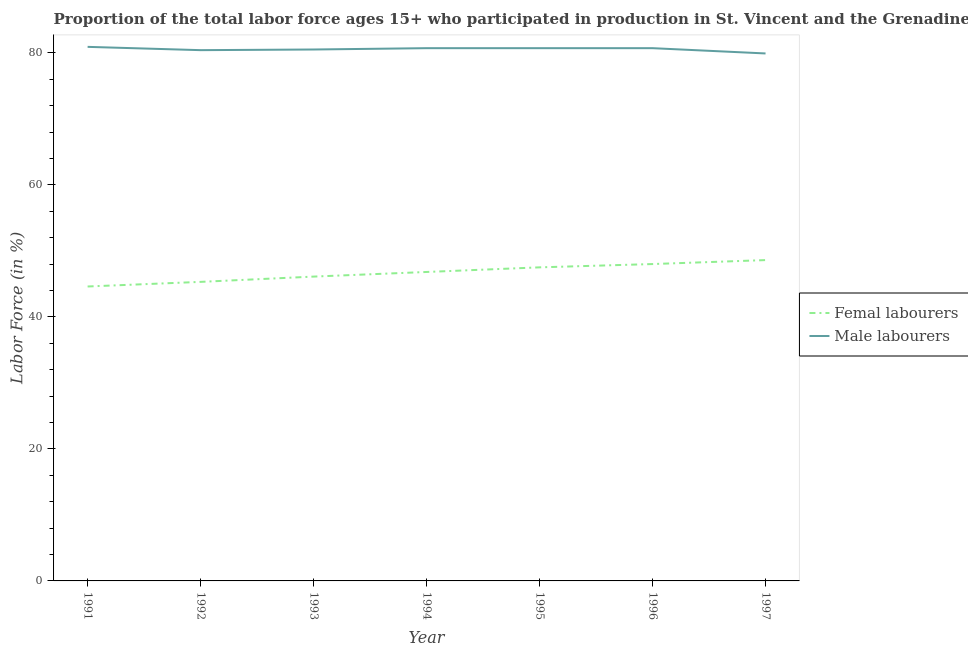What is the percentage of male labour force in 1997?
Your response must be concise. 79.9. Across all years, what is the maximum percentage of male labour force?
Offer a terse response. 80.9. Across all years, what is the minimum percentage of male labour force?
Provide a succinct answer. 79.9. In which year was the percentage of male labour force maximum?
Provide a short and direct response. 1991. In which year was the percentage of male labour force minimum?
Ensure brevity in your answer.  1997. What is the total percentage of male labour force in the graph?
Offer a terse response. 563.8. What is the difference between the percentage of female labor force in 1991 and that in 1996?
Make the answer very short. -3.4. What is the difference between the percentage of male labour force in 1996 and the percentage of female labor force in 1993?
Provide a succinct answer. 34.6. What is the average percentage of male labour force per year?
Your answer should be compact. 80.54. In the year 1997, what is the difference between the percentage of female labor force and percentage of male labour force?
Your response must be concise. -31.3. In how many years, is the percentage of male labour force greater than 28 %?
Your response must be concise. 7. What is the ratio of the percentage of female labor force in 1991 to that in 1994?
Ensure brevity in your answer.  0.95. Is the percentage of male labour force in 1996 less than that in 1997?
Your answer should be very brief. No. Is the difference between the percentage of female labor force in 1996 and 1997 greater than the difference between the percentage of male labour force in 1996 and 1997?
Your response must be concise. No. What is the difference between the highest and the second highest percentage of female labor force?
Offer a terse response. 0.6. What is the difference between the highest and the lowest percentage of male labour force?
Give a very brief answer. 1. In how many years, is the percentage of male labour force greater than the average percentage of male labour force taken over all years?
Ensure brevity in your answer.  4. Does the percentage of male labour force monotonically increase over the years?
Provide a short and direct response. No. Is the percentage of female labor force strictly less than the percentage of male labour force over the years?
Provide a short and direct response. Yes. How many lines are there?
Give a very brief answer. 2. Does the graph contain any zero values?
Your answer should be compact. No. Does the graph contain grids?
Give a very brief answer. No. How many legend labels are there?
Provide a short and direct response. 2. What is the title of the graph?
Give a very brief answer. Proportion of the total labor force ages 15+ who participated in production in St. Vincent and the Grenadines. What is the label or title of the X-axis?
Your answer should be very brief. Year. What is the label or title of the Y-axis?
Give a very brief answer. Labor Force (in %). What is the Labor Force (in %) of Femal labourers in 1991?
Provide a short and direct response. 44.6. What is the Labor Force (in %) in Male labourers in 1991?
Keep it short and to the point. 80.9. What is the Labor Force (in %) in Femal labourers in 1992?
Provide a succinct answer. 45.3. What is the Labor Force (in %) in Male labourers in 1992?
Provide a succinct answer. 80.4. What is the Labor Force (in %) in Femal labourers in 1993?
Provide a succinct answer. 46.1. What is the Labor Force (in %) in Male labourers in 1993?
Offer a terse response. 80.5. What is the Labor Force (in %) in Femal labourers in 1994?
Your answer should be compact. 46.8. What is the Labor Force (in %) of Male labourers in 1994?
Provide a short and direct response. 80.7. What is the Labor Force (in %) of Femal labourers in 1995?
Your response must be concise. 47.5. What is the Labor Force (in %) of Male labourers in 1995?
Your answer should be compact. 80.7. What is the Labor Force (in %) in Femal labourers in 1996?
Provide a succinct answer. 48. What is the Labor Force (in %) in Male labourers in 1996?
Offer a very short reply. 80.7. What is the Labor Force (in %) of Femal labourers in 1997?
Your answer should be compact. 48.6. What is the Labor Force (in %) in Male labourers in 1997?
Your answer should be very brief. 79.9. Across all years, what is the maximum Labor Force (in %) of Femal labourers?
Make the answer very short. 48.6. Across all years, what is the maximum Labor Force (in %) of Male labourers?
Provide a succinct answer. 80.9. Across all years, what is the minimum Labor Force (in %) in Femal labourers?
Ensure brevity in your answer.  44.6. Across all years, what is the minimum Labor Force (in %) of Male labourers?
Your answer should be compact. 79.9. What is the total Labor Force (in %) in Femal labourers in the graph?
Make the answer very short. 326.9. What is the total Labor Force (in %) in Male labourers in the graph?
Provide a short and direct response. 563.8. What is the difference between the Labor Force (in %) in Femal labourers in 1991 and that in 1992?
Offer a very short reply. -0.7. What is the difference between the Labor Force (in %) of Femal labourers in 1991 and that in 1993?
Your response must be concise. -1.5. What is the difference between the Labor Force (in %) of Male labourers in 1991 and that in 1993?
Offer a terse response. 0.4. What is the difference between the Labor Force (in %) in Femal labourers in 1991 and that in 1995?
Ensure brevity in your answer.  -2.9. What is the difference between the Labor Force (in %) of Male labourers in 1991 and that in 1997?
Your answer should be very brief. 1. What is the difference between the Labor Force (in %) of Male labourers in 1992 and that in 1994?
Provide a succinct answer. -0.3. What is the difference between the Labor Force (in %) of Male labourers in 1992 and that in 1995?
Offer a very short reply. -0.3. What is the difference between the Labor Force (in %) of Femal labourers in 1992 and that in 1996?
Provide a short and direct response. -2.7. What is the difference between the Labor Force (in %) in Male labourers in 1992 and that in 1996?
Make the answer very short. -0.3. What is the difference between the Labor Force (in %) of Male labourers in 1992 and that in 1997?
Offer a very short reply. 0.5. What is the difference between the Labor Force (in %) of Male labourers in 1993 and that in 1994?
Your answer should be compact. -0.2. What is the difference between the Labor Force (in %) of Male labourers in 1993 and that in 1995?
Keep it short and to the point. -0.2. What is the difference between the Labor Force (in %) in Femal labourers in 1993 and that in 1996?
Make the answer very short. -1.9. What is the difference between the Labor Force (in %) of Male labourers in 1993 and that in 1996?
Your answer should be compact. -0.2. What is the difference between the Labor Force (in %) of Femal labourers in 1994 and that in 1995?
Offer a very short reply. -0.7. What is the difference between the Labor Force (in %) in Femal labourers in 1994 and that in 1996?
Keep it short and to the point. -1.2. What is the difference between the Labor Force (in %) of Male labourers in 1994 and that in 1996?
Make the answer very short. 0. What is the difference between the Labor Force (in %) in Femal labourers in 1994 and that in 1997?
Ensure brevity in your answer.  -1.8. What is the difference between the Labor Force (in %) in Femal labourers in 1995 and that in 1996?
Offer a terse response. -0.5. What is the difference between the Labor Force (in %) of Male labourers in 1995 and that in 1996?
Give a very brief answer. 0. What is the difference between the Labor Force (in %) in Femal labourers in 1995 and that in 1997?
Keep it short and to the point. -1.1. What is the difference between the Labor Force (in %) in Male labourers in 1995 and that in 1997?
Your response must be concise. 0.8. What is the difference between the Labor Force (in %) in Femal labourers in 1996 and that in 1997?
Give a very brief answer. -0.6. What is the difference between the Labor Force (in %) of Femal labourers in 1991 and the Labor Force (in %) of Male labourers in 1992?
Give a very brief answer. -35.8. What is the difference between the Labor Force (in %) of Femal labourers in 1991 and the Labor Force (in %) of Male labourers in 1993?
Provide a succinct answer. -35.9. What is the difference between the Labor Force (in %) of Femal labourers in 1991 and the Labor Force (in %) of Male labourers in 1994?
Offer a terse response. -36.1. What is the difference between the Labor Force (in %) of Femal labourers in 1991 and the Labor Force (in %) of Male labourers in 1995?
Provide a short and direct response. -36.1. What is the difference between the Labor Force (in %) in Femal labourers in 1991 and the Labor Force (in %) in Male labourers in 1996?
Offer a terse response. -36.1. What is the difference between the Labor Force (in %) in Femal labourers in 1991 and the Labor Force (in %) in Male labourers in 1997?
Provide a short and direct response. -35.3. What is the difference between the Labor Force (in %) in Femal labourers in 1992 and the Labor Force (in %) in Male labourers in 1993?
Provide a short and direct response. -35.2. What is the difference between the Labor Force (in %) in Femal labourers in 1992 and the Labor Force (in %) in Male labourers in 1994?
Your answer should be very brief. -35.4. What is the difference between the Labor Force (in %) in Femal labourers in 1992 and the Labor Force (in %) in Male labourers in 1995?
Give a very brief answer. -35.4. What is the difference between the Labor Force (in %) in Femal labourers in 1992 and the Labor Force (in %) in Male labourers in 1996?
Ensure brevity in your answer.  -35.4. What is the difference between the Labor Force (in %) in Femal labourers in 1992 and the Labor Force (in %) in Male labourers in 1997?
Keep it short and to the point. -34.6. What is the difference between the Labor Force (in %) in Femal labourers in 1993 and the Labor Force (in %) in Male labourers in 1994?
Provide a short and direct response. -34.6. What is the difference between the Labor Force (in %) of Femal labourers in 1993 and the Labor Force (in %) of Male labourers in 1995?
Offer a very short reply. -34.6. What is the difference between the Labor Force (in %) in Femal labourers in 1993 and the Labor Force (in %) in Male labourers in 1996?
Keep it short and to the point. -34.6. What is the difference between the Labor Force (in %) in Femal labourers in 1993 and the Labor Force (in %) in Male labourers in 1997?
Give a very brief answer. -33.8. What is the difference between the Labor Force (in %) in Femal labourers in 1994 and the Labor Force (in %) in Male labourers in 1995?
Provide a short and direct response. -33.9. What is the difference between the Labor Force (in %) in Femal labourers in 1994 and the Labor Force (in %) in Male labourers in 1996?
Provide a succinct answer. -33.9. What is the difference between the Labor Force (in %) in Femal labourers in 1994 and the Labor Force (in %) in Male labourers in 1997?
Give a very brief answer. -33.1. What is the difference between the Labor Force (in %) of Femal labourers in 1995 and the Labor Force (in %) of Male labourers in 1996?
Offer a terse response. -33.2. What is the difference between the Labor Force (in %) of Femal labourers in 1995 and the Labor Force (in %) of Male labourers in 1997?
Ensure brevity in your answer.  -32.4. What is the difference between the Labor Force (in %) of Femal labourers in 1996 and the Labor Force (in %) of Male labourers in 1997?
Give a very brief answer. -31.9. What is the average Labor Force (in %) in Femal labourers per year?
Give a very brief answer. 46.7. What is the average Labor Force (in %) of Male labourers per year?
Give a very brief answer. 80.54. In the year 1991, what is the difference between the Labor Force (in %) of Femal labourers and Labor Force (in %) of Male labourers?
Keep it short and to the point. -36.3. In the year 1992, what is the difference between the Labor Force (in %) of Femal labourers and Labor Force (in %) of Male labourers?
Offer a terse response. -35.1. In the year 1993, what is the difference between the Labor Force (in %) of Femal labourers and Labor Force (in %) of Male labourers?
Ensure brevity in your answer.  -34.4. In the year 1994, what is the difference between the Labor Force (in %) of Femal labourers and Labor Force (in %) of Male labourers?
Your answer should be compact. -33.9. In the year 1995, what is the difference between the Labor Force (in %) in Femal labourers and Labor Force (in %) in Male labourers?
Keep it short and to the point. -33.2. In the year 1996, what is the difference between the Labor Force (in %) in Femal labourers and Labor Force (in %) in Male labourers?
Your answer should be very brief. -32.7. In the year 1997, what is the difference between the Labor Force (in %) of Femal labourers and Labor Force (in %) of Male labourers?
Keep it short and to the point. -31.3. What is the ratio of the Labor Force (in %) in Femal labourers in 1991 to that in 1992?
Give a very brief answer. 0.98. What is the ratio of the Labor Force (in %) in Femal labourers in 1991 to that in 1993?
Make the answer very short. 0.97. What is the ratio of the Labor Force (in %) in Femal labourers in 1991 to that in 1994?
Your answer should be very brief. 0.95. What is the ratio of the Labor Force (in %) of Femal labourers in 1991 to that in 1995?
Your response must be concise. 0.94. What is the ratio of the Labor Force (in %) in Femal labourers in 1991 to that in 1996?
Give a very brief answer. 0.93. What is the ratio of the Labor Force (in %) of Male labourers in 1991 to that in 1996?
Your answer should be very brief. 1. What is the ratio of the Labor Force (in %) in Femal labourers in 1991 to that in 1997?
Offer a very short reply. 0.92. What is the ratio of the Labor Force (in %) in Male labourers in 1991 to that in 1997?
Give a very brief answer. 1.01. What is the ratio of the Labor Force (in %) of Femal labourers in 1992 to that in 1993?
Keep it short and to the point. 0.98. What is the ratio of the Labor Force (in %) of Male labourers in 1992 to that in 1993?
Give a very brief answer. 1. What is the ratio of the Labor Force (in %) in Femal labourers in 1992 to that in 1994?
Your answer should be compact. 0.97. What is the ratio of the Labor Force (in %) in Male labourers in 1992 to that in 1994?
Offer a very short reply. 1. What is the ratio of the Labor Force (in %) of Femal labourers in 1992 to that in 1995?
Your response must be concise. 0.95. What is the ratio of the Labor Force (in %) in Femal labourers in 1992 to that in 1996?
Your answer should be compact. 0.94. What is the ratio of the Labor Force (in %) of Femal labourers in 1992 to that in 1997?
Your answer should be very brief. 0.93. What is the ratio of the Labor Force (in %) in Femal labourers in 1993 to that in 1994?
Your answer should be compact. 0.98. What is the ratio of the Labor Force (in %) of Male labourers in 1993 to that in 1994?
Your response must be concise. 1. What is the ratio of the Labor Force (in %) in Femal labourers in 1993 to that in 1995?
Offer a terse response. 0.97. What is the ratio of the Labor Force (in %) in Male labourers in 1993 to that in 1995?
Your answer should be very brief. 1. What is the ratio of the Labor Force (in %) in Femal labourers in 1993 to that in 1996?
Provide a succinct answer. 0.96. What is the ratio of the Labor Force (in %) of Male labourers in 1993 to that in 1996?
Offer a terse response. 1. What is the ratio of the Labor Force (in %) in Femal labourers in 1993 to that in 1997?
Your response must be concise. 0.95. What is the ratio of the Labor Force (in %) in Male labourers in 1993 to that in 1997?
Your answer should be very brief. 1.01. What is the ratio of the Labor Force (in %) in Male labourers in 1994 to that in 1996?
Your answer should be compact. 1. What is the ratio of the Labor Force (in %) of Femal labourers in 1994 to that in 1997?
Provide a succinct answer. 0.96. What is the ratio of the Labor Force (in %) in Male labourers in 1995 to that in 1996?
Provide a short and direct response. 1. What is the ratio of the Labor Force (in %) in Femal labourers in 1995 to that in 1997?
Provide a succinct answer. 0.98. What is the ratio of the Labor Force (in %) in Male labourers in 1995 to that in 1997?
Give a very brief answer. 1.01. What is the difference between the highest and the second highest Labor Force (in %) of Male labourers?
Keep it short and to the point. 0.2. What is the difference between the highest and the lowest Labor Force (in %) in Femal labourers?
Make the answer very short. 4. 